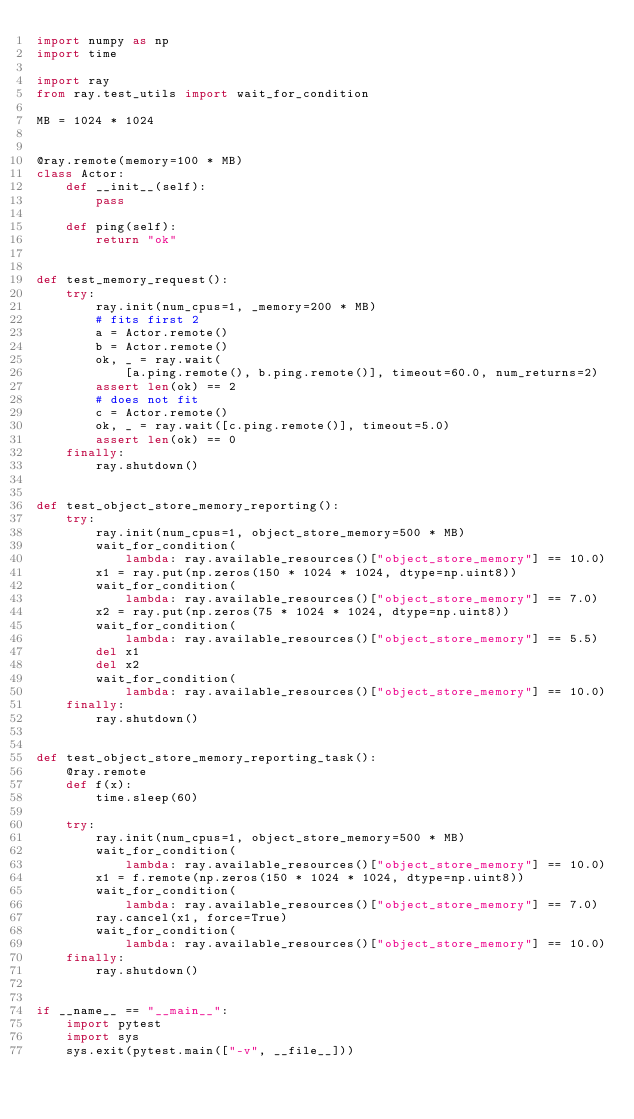Convert code to text. <code><loc_0><loc_0><loc_500><loc_500><_Python_>import numpy as np
import time

import ray
from ray.test_utils import wait_for_condition

MB = 1024 * 1024


@ray.remote(memory=100 * MB)
class Actor:
    def __init__(self):
        pass

    def ping(self):
        return "ok"


def test_memory_request():
    try:
        ray.init(num_cpus=1, _memory=200 * MB)
        # fits first 2
        a = Actor.remote()
        b = Actor.remote()
        ok, _ = ray.wait(
            [a.ping.remote(), b.ping.remote()], timeout=60.0, num_returns=2)
        assert len(ok) == 2
        # does not fit
        c = Actor.remote()
        ok, _ = ray.wait([c.ping.remote()], timeout=5.0)
        assert len(ok) == 0
    finally:
        ray.shutdown()


def test_object_store_memory_reporting():
    try:
        ray.init(num_cpus=1, object_store_memory=500 * MB)
        wait_for_condition(
            lambda: ray.available_resources()["object_store_memory"] == 10.0)
        x1 = ray.put(np.zeros(150 * 1024 * 1024, dtype=np.uint8))
        wait_for_condition(
            lambda: ray.available_resources()["object_store_memory"] == 7.0)
        x2 = ray.put(np.zeros(75 * 1024 * 1024, dtype=np.uint8))
        wait_for_condition(
            lambda: ray.available_resources()["object_store_memory"] == 5.5)
        del x1
        del x2
        wait_for_condition(
            lambda: ray.available_resources()["object_store_memory"] == 10.0)
    finally:
        ray.shutdown()


def test_object_store_memory_reporting_task():
    @ray.remote
    def f(x):
        time.sleep(60)

    try:
        ray.init(num_cpus=1, object_store_memory=500 * MB)
        wait_for_condition(
            lambda: ray.available_resources()["object_store_memory"] == 10.0)
        x1 = f.remote(np.zeros(150 * 1024 * 1024, dtype=np.uint8))
        wait_for_condition(
            lambda: ray.available_resources()["object_store_memory"] == 7.0)
        ray.cancel(x1, force=True)
        wait_for_condition(
            lambda: ray.available_resources()["object_store_memory"] == 10.0)
    finally:
        ray.shutdown()


if __name__ == "__main__":
    import pytest
    import sys
    sys.exit(pytest.main(["-v", __file__]))
</code> 